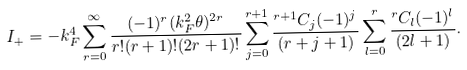Convert formula to latex. <formula><loc_0><loc_0><loc_500><loc_500>I _ { + } = - k _ { F } ^ { 4 } \sum _ { r = 0 } ^ { \infty } \frac { ( - 1 ) ^ { r } ( k _ { F } ^ { 2 } \theta ) ^ { 2 r } } { r ! ( r + 1 ) ! ( 2 r + 1 ) ! } \sum _ { j = 0 } ^ { r + 1 } \frac { ^ { r + 1 } C _ { j } ( - 1 ) ^ { j } } { ( r + j + 1 ) } \sum _ { l = 0 } ^ { r } \frac { ^ { r } C _ { l } ( - 1 ) ^ { l } } { ( 2 l + 1 ) } .</formula> 